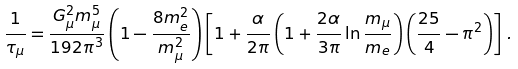Convert formula to latex. <formula><loc_0><loc_0><loc_500><loc_500>\frac { 1 } { \tau _ { \mu } } = \frac { G ^ { 2 } _ { \mu } m ^ { 5 } _ { \mu } } { 1 9 2 \pi ^ { 3 } } \left ( 1 - \frac { 8 m ^ { 2 } _ { e } } { m ^ { 2 } _ { \mu } } \right ) \left [ 1 + \frac { \alpha } { 2 \pi } \left ( 1 + \frac { 2 \alpha } { 3 \pi } \ln \frac { m _ { \mu } } { m _ { e } } \right ) \left ( \frac { 2 5 } { 4 } - \pi ^ { 2 } \right ) \right ] \, .</formula> 